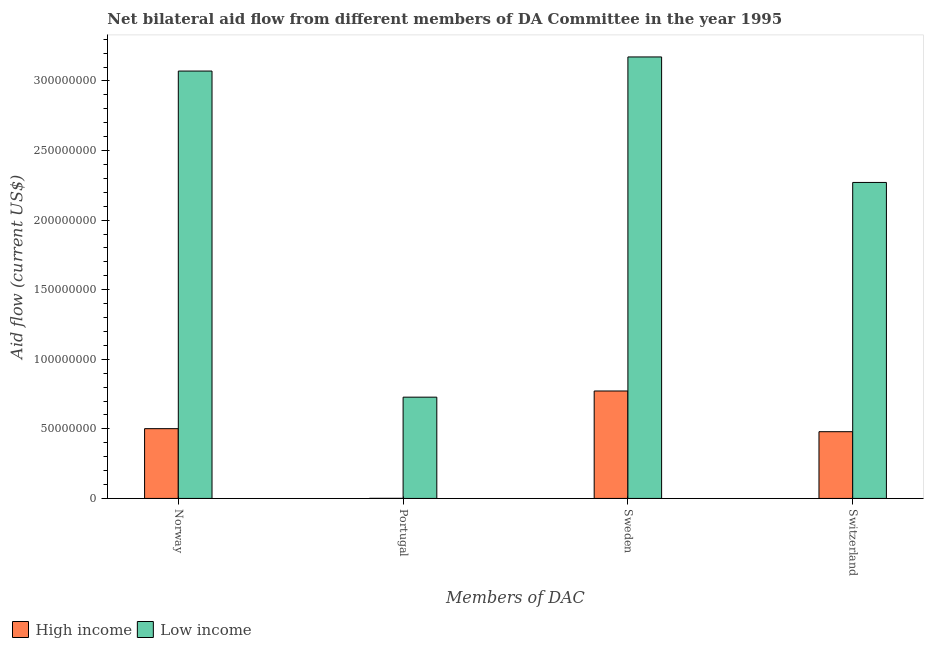How many different coloured bars are there?
Make the answer very short. 2. How many groups of bars are there?
Ensure brevity in your answer.  4. How many bars are there on the 4th tick from the left?
Provide a short and direct response. 2. What is the label of the 1st group of bars from the left?
Provide a succinct answer. Norway. What is the amount of aid given by portugal in High income?
Provide a short and direct response. 6.00e+04. Across all countries, what is the maximum amount of aid given by norway?
Your answer should be compact. 3.07e+08. Across all countries, what is the minimum amount of aid given by norway?
Make the answer very short. 5.01e+07. What is the total amount of aid given by switzerland in the graph?
Make the answer very short. 2.75e+08. What is the difference between the amount of aid given by norway in High income and that in Low income?
Ensure brevity in your answer.  -2.57e+08. What is the difference between the amount of aid given by norway in Low income and the amount of aid given by switzerland in High income?
Offer a very short reply. 2.59e+08. What is the average amount of aid given by portugal per country?
Your answer should be very brief. 3.64e+07. What is the difference between the amount of aid given by switzerland and amount of aid given by norway in High income?
Provide a short and direct response. -2.18e+06. What is the ratio of the amount of aid given by portugal in High income to that in Low income?
Your response must be concise. 0. Is the difference between the amount of aid given by portugal in High income and Low income greater than the difference between the amount of aid given by norway in High income and Low income?
Ensure brevity in your answer.  Yes. What is the difference between the highest and the second highest amount of aid given by norway?
Give a very brief answer. 2.57e+08. What is the difference between the highest and the lowest amount of aid given by switzerland?
Keep it short and to the point. 1.79e+08. In how many countries, is the amount of aid given by sweden greater than the average amount of aid given by sweden taken over all countries?
Keep it short and to the point. 1. Is it the case that in every country, the sum of the amount of aid given by norway and amount of aid given by portugal is greater than the sum of amount of aid given by switzerland and amount of aid given by sweden?
Your answer should be compact. No. What does the 2nd bar from the left in Sweden represents?
Keep it short and to the point. Low income. Are all the bars in the graph horizontal?
Offer a terse response. No. What is the difference between two consecutive major ticks on the Y-axis?
Offer a terse response. 5.00e+07. Are the values on the major ticks of Y-axis written in scientific E-notation?
Your response must be concise. No. Does the graph contain grids?
Provide a succinct answer. No. What is the title of the graph?
Offer a terse response. Net bilateral aid flow from different members of DA Committee in the year 1995. Does "Argentina" appear as one of the legend labels in the graph?
Make the answer very short. No. What is the label or title of the X-axis?
Offer a very short reply. Members of DAC. What is the Aid flow (current US$) of High income in Norway?
Offer a terse response. 5.01e+07. What is the Aid flow (current US$) in Low income in Norway?
Your answer should be compact. 3.07e+08. What is the Aid flow (current US$) in Low income in Portugal?
Provide a succinct answer. 7.28e+07. What is the Aid flow (current US$) of High income in Sweden?
Your response must be concise. 7.72e+07. What is the Aid flow (current US$) of Low income in Sweden?
Your response must be concise. 3.17e+08. What is the Aid flow (current US$) of High income in Switzerland?
Give a very brief answer. 4.80e+07. What is the Aid flow (current US$) in Low income in Switzerland?
Keep it short and to the point. 2.27e+08. Across all Members of DAC, what is the maximum Aid flow (current US$) in High income?
Your answer should be compact. 7.72e+07. Across all Members of DAC, what is the maximum Aid flow (current US$) in Low income?
Offer a terse response. 3.17e+08. Across all Members of DAC, what is the minimum Aid flow (current US$) in High income?
Offer a very short reply. 6.00e+04. Across all Members of DAC, what is the minimum Aid flow (current US$) of Low income?
Offer a terse response. 7.28e+07. What is the total Aid flow (current US$) of High income in the graph?
Your answer should be very brief. 1.75e+08. What is the total Aid flow (current US$) in Low income in the graph?
Your answer should be compact. 9.24e+08. What is the difference between the Aid flow (current US$) of High income in Norway and that in Portugal?
Provide a short and direct response. 5.01e+07. What is the difference between the Aid flow (current US$) of Low income in Norway and that in Portugal?
Offer a terse response. 2.34e+08. What is the difference between the Aid flow (current US$) of High income in Norway and that in Sweden?
Provide a short and direct response. -2.71e+07. What is the difference between the Aid flow (current US$) of Low income in Norway and that in Sweden?
Offer a terse response. -1.01e+07. What is the difference between the Aid flow (current US$) of High income in Norway and that in Switzerland?
Your answer should be very brief. 2.18e+06. What is the difference between the Aid flow (current US$) of Low income in Norway and that in Switzerland?
Your answer should be compact. 8.00e+07. What is the difference between the Aid flow (current US$) in High income in Portugal and that in Sweden?
Offer a very short reply. -7.71e+07. What is the difference between the Aid flow (current US$) in Low income in Portugal and that in Sweden?
Your answer should be very brief. -2.44e+08. What is the difference between the Aid flow (current US$) in High income in Portugal and that in Switzerland?
Offer a very short reply. -4.79e+07. What is the difference between the Aid flow (current US$) of Low income in Portugal and that in Switzerland?
Give a very brief answer. -1.54e+08. What is the difference between the Aid flow (current US$) in High income in Sweden and that in Switzerland?
Your answer should be very brief. 2.92e+07. What is the difference between the Aid flow (current US$) of Low income in Sweden and that in Switzerland?
Provide a short and direct response. 9.02e+07. What is the difference between the Aid flow (current US$) in High income in Norway and the Aid flow (current US$) in Low income in Portugal?
Give a very brief answer. -2.26e+07. What is the difference between the Aid flow (current US$) in High income in Norway and the Aid flow (current US$) in Low income in Sweden?
Provide a short and direct response. -2.67e+08. What is the difference between the Aid flow (current US$) of High income in Norway and the Aid flow (current US$) of Low income in Switzerland?
Offer a very short reply. -1.77e+08. What is the difference between the Aid flow (current US$) in High income in Portugal and the Aid flow (current US$) in Low income in Sweden?
Keep it short and to the point. -3.17e+08. What is the difference between the Aid flow (current US$) in High income in Portugal and the Aid flow (current US$) in Low income in Switzerland?
Provide a short and direct response. -2.27e+08. What is the difference between the Aid flow (current US$) of High income in Sweden and the Aid flow (current US$) of Low income in Switzerland?
Make the answer very short. -1.50e+08. What is the average Aid flow (current US$) of High income per Members of DAC?
Ensure brevity in your answer.  4.38e+07. What is the average Aid flow (current US$) of Low income per Members of DAC?
Give a very brief answer. 2.31e+08. What is the difference between the Aid flow (current US$) of High income and Aid flow (current US$) of Low income in Norway?
Make the answer very short. -2.57e+08. What is the difference between the Aid flow (current US$) in High income and Aid flow (current US$) in Low income in Portugal?
Your response must be concise. -7.27e+07. What is the difference between the Aid flow (current US$) of High income and Aid flow (current US$) of Low income in Sweden?
Keep it short and to the point. -2.40e+08. What is the difference between the Aid flow (current US$) in High income and Aid flow (current US$) in Low income in Switzerland?
Provide a short and direct response. -1.79e+08. What is the ratio of the Aid flow (current US$) in High income in Norway to that in Portugal?
Make the answer very short. 835.5. What is the ratio of the Aid flow (current US$) in Low income in Norway to that in Portugal?
Make the answer very short. 4.22. What is the ratio of the Aid flow (current US$) in High income in Norway to that in Sweden?
Give a very brief answer. 0.65. What is the ratio of the Aid flow (current US$) in Low income in Norway to that in Sweden?
Your answer should be very brief. 0.97. What is the ratio of the Aid flow (current US$) of High income in Norway to that in Switzerland?
Offer a terse response. 1.05. What is the ratio of the Aid flow (current US$) of Low income in Norway to that in Switzerland?
Your response must be concise. 1.35. What is the ratio of the Aid flow (current US$) in High income in Portugal to that in Sweden?
Ensure brevity in your answer.  0. What is the ratio of the Aid flow (current US$) in Low income in Portugal to that in Sweden?
Ensure brevity in your answer.  0.23. What is the ratio of the Aid flow (current US$) in High income in Portugal to that in Switzerland?
Offer a terse response. 0. What is the ratio of the Aid flow (current US$) in Low income in Portugal to that in Switzerland?
Give a very brief answer. 0.32. What is the ratio of the Aid flow (current US$) in High income in Sweden to that in Switzerland?
Provide a succinct answer. 1.61. What is the ratio of the Aid flow (current US$) in Low income in Sweden to that in Switzerland?
Offer a terse response. 1.4. What is the difference between the highest and the second highest Aid flow (current US$) in High income?
Your answer should be very brief. 2.71e+07. What is the difference between the highest and the second highest Aid flow (current US$) in Low income?
Provide a succinct answer. 1.01e+07. What is the difference between the highest and the lowest Aid flow (current US$) of High income?
Your response must be concise. 7.71e+07. What is the difference between the highest and the lowest Aid flow (current US$) of Low income?
Offer a terse response. 2.44e+08. 